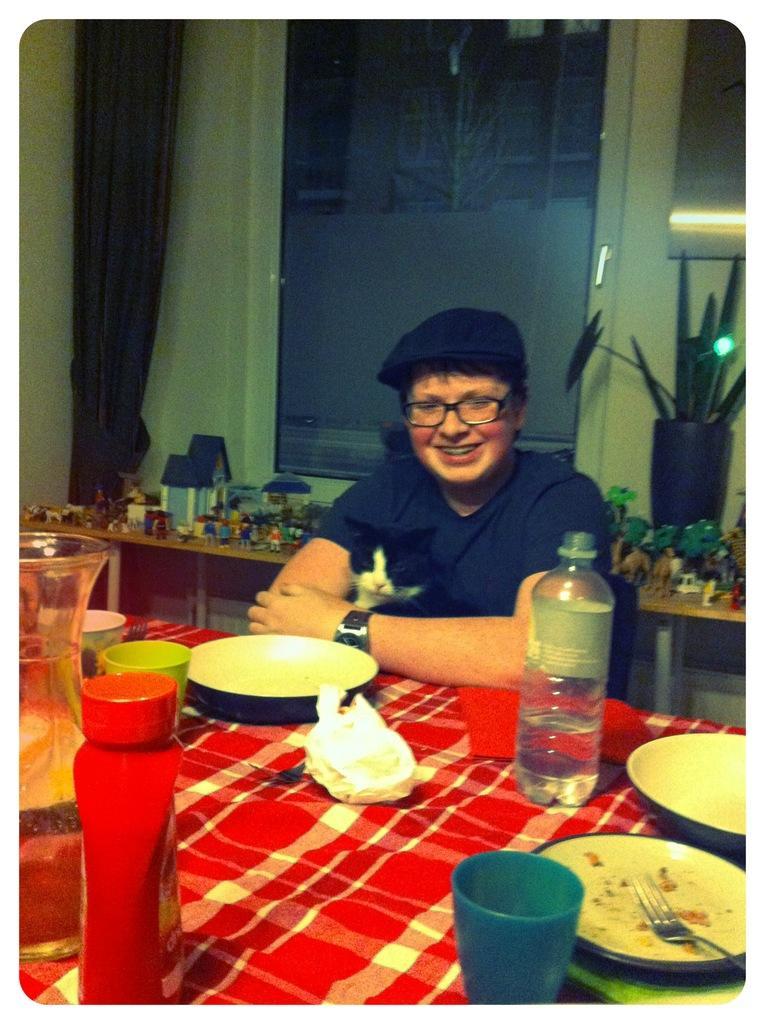Could you give a brief overview of what you see in this image? This is a picture of a man in black t shirt sitting on a chair. In front of the man there is a table on the table there are bottle, plate, tissues, spoon, cup and a jar. Background of the man there is a wall. 